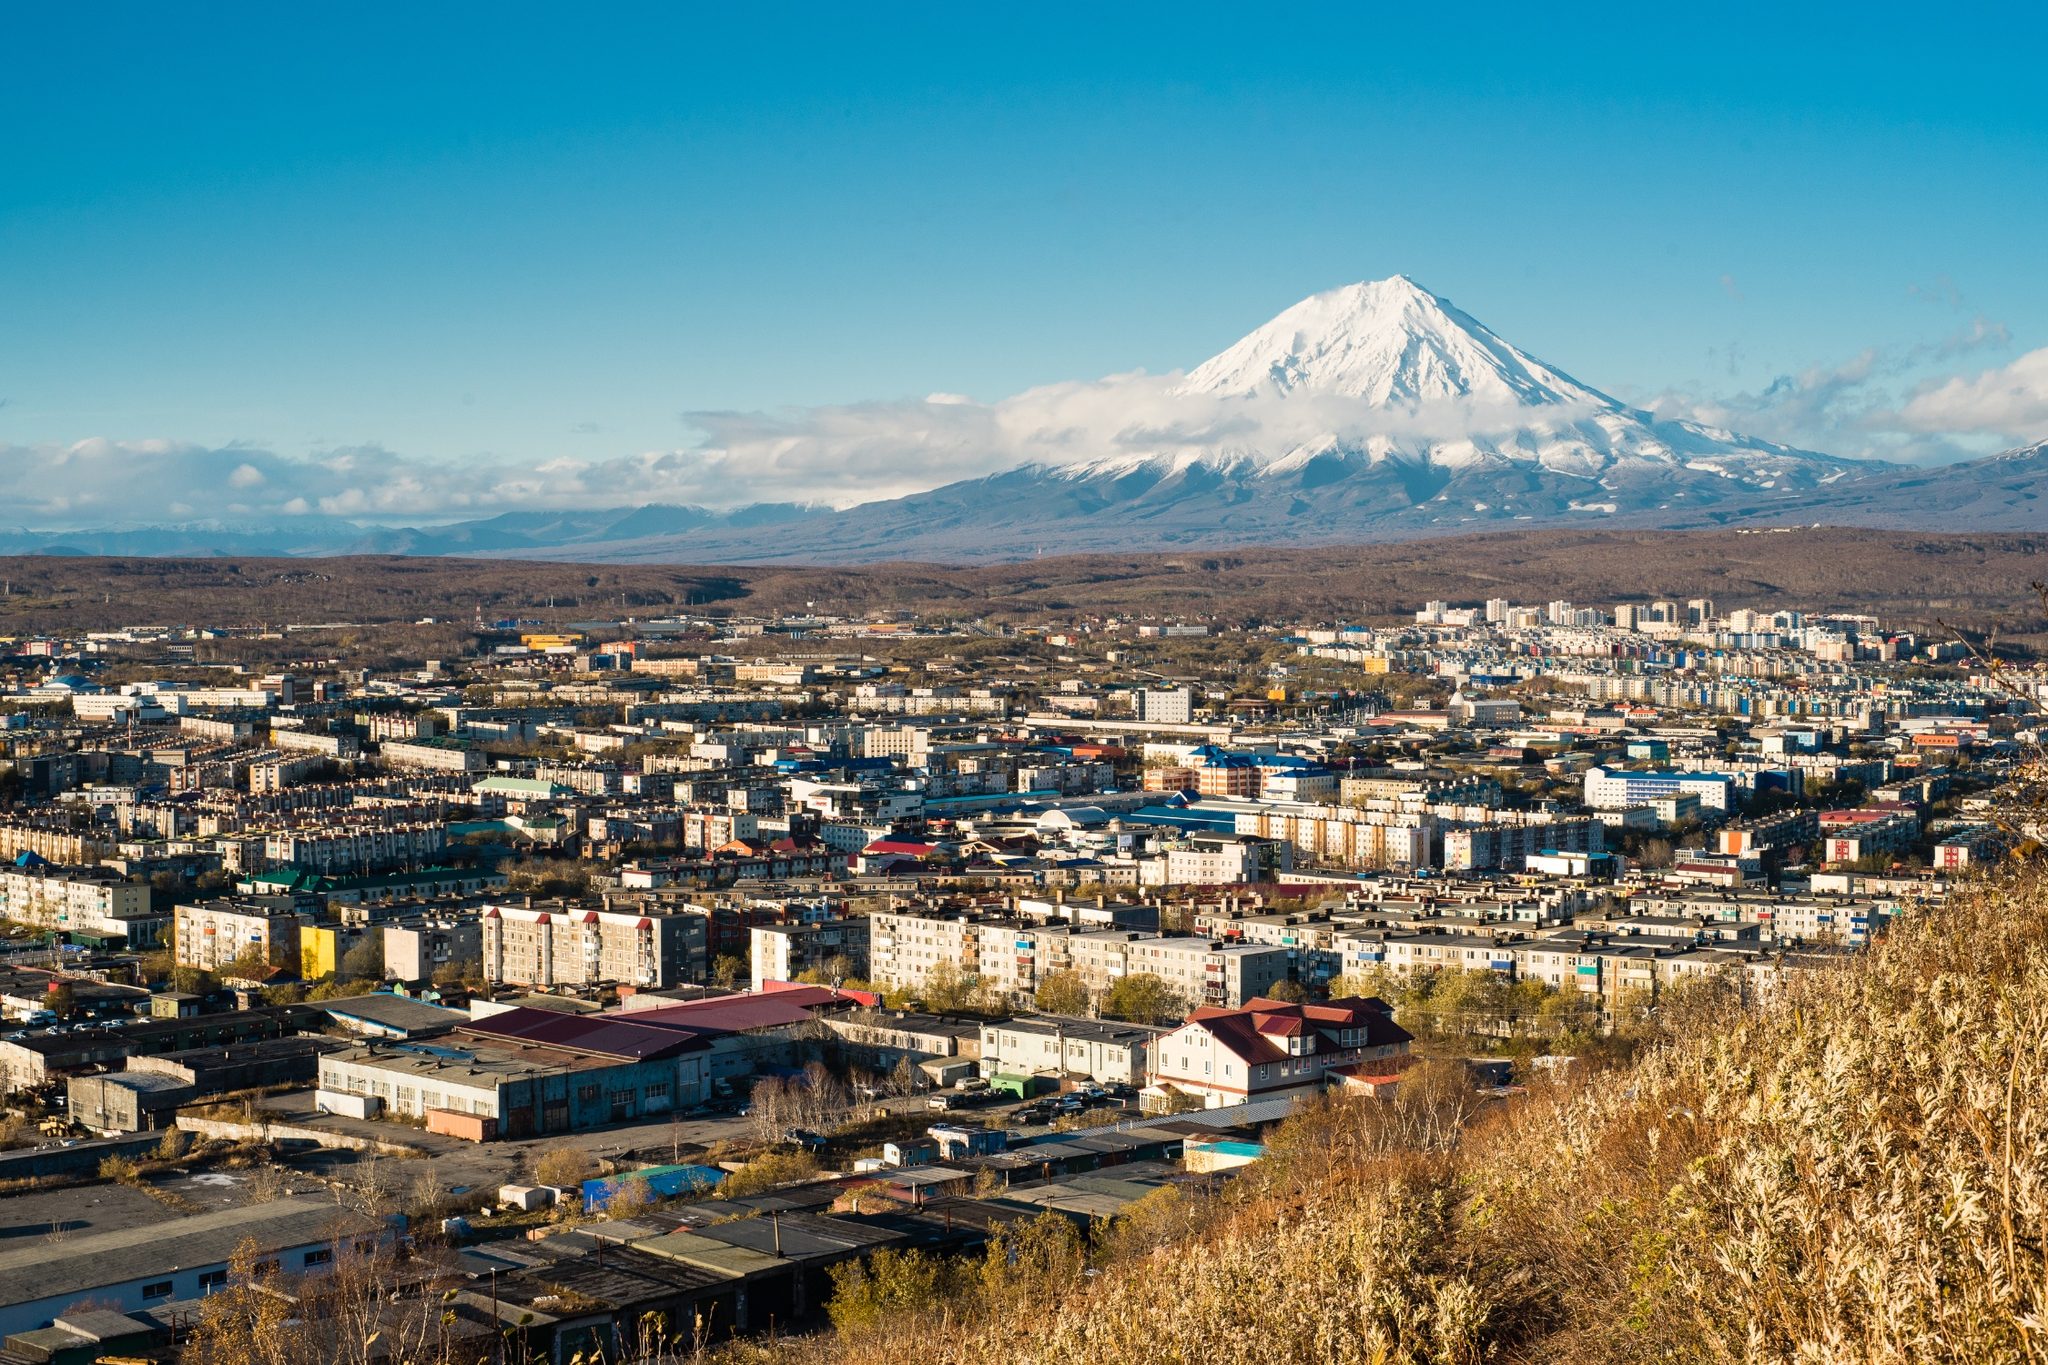What can you tell me about the architectural styles present in Petropavlovsk-Kamchatsky? The architecture in Petropavlovsk-Kamchatsky features a mix of Soviet-era residential buildings and modern construction. The city's architectural landscape is predominantly characterized by functional, utilitarian Soviet blocks, designed to house many residents efficiently. These buildings often have a simple, boxy design with little ornamentation. However, there has been a surge in newer developments featuring more contemporary styles with improved aesthetics and functionality. These newer buildings often incorporate vibrant colors and innovative designs, aiming to break the monotony of Soviet architecture. Overall, the city presents a blend of historical and modern architectural influences, reflecting its evolving urban identity. Why is the volcano such an important feature of this city? The Koryaksky volcano is a prominent natural landmark and an integral part of Petropavlovsk-Kamchatsky’s identity. Its imposing and majestic presence creates a dramatic backdrop, symbolizing the raw power of nature that coexists with human settlement. It not only serves as a natural attraction for tourists, increasing local tourism, but also provides a geographic and cultural point of reference for the inhabitants. Additionally, being part of the Pacific Ring of Fire, the volcano exemplifies the dynamic geological activity that shapes the region, reminding the residents of both the beauty and potential hazards of living in such a unique location. 